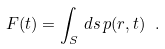<formula> <loc_0><loc_0><loc_500><loc_500>F ( t ) = \int _ { S } \, d s \, p ( r , t ) \ .</formula> 